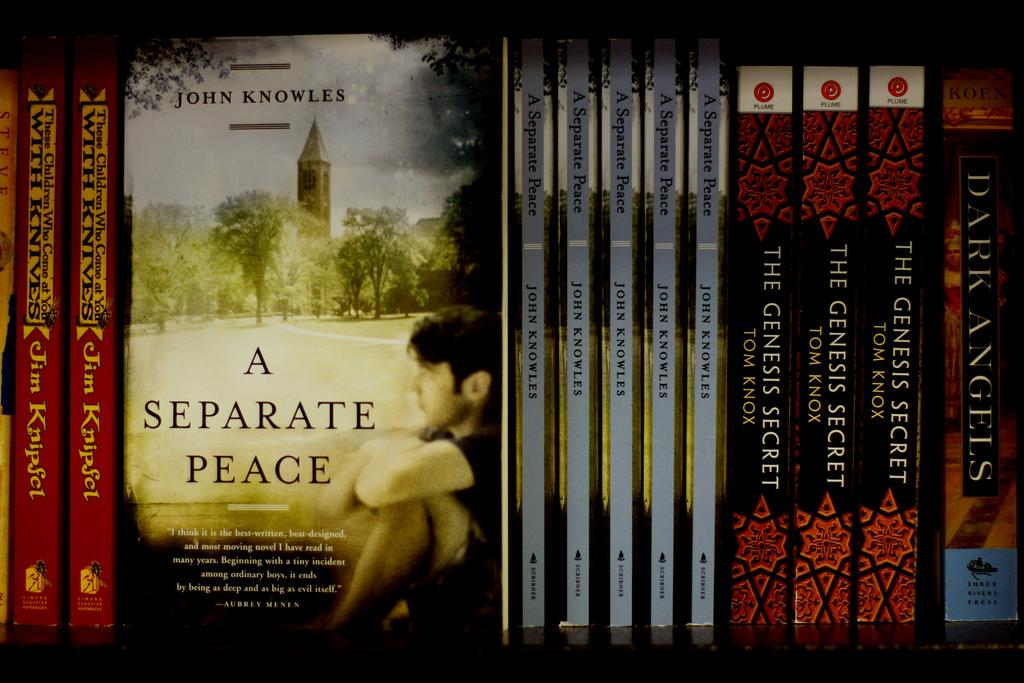<image>
Give a short and clear explanation of the subsequent image. Books placed on a shelf with "A Separate Peace" in the front. 